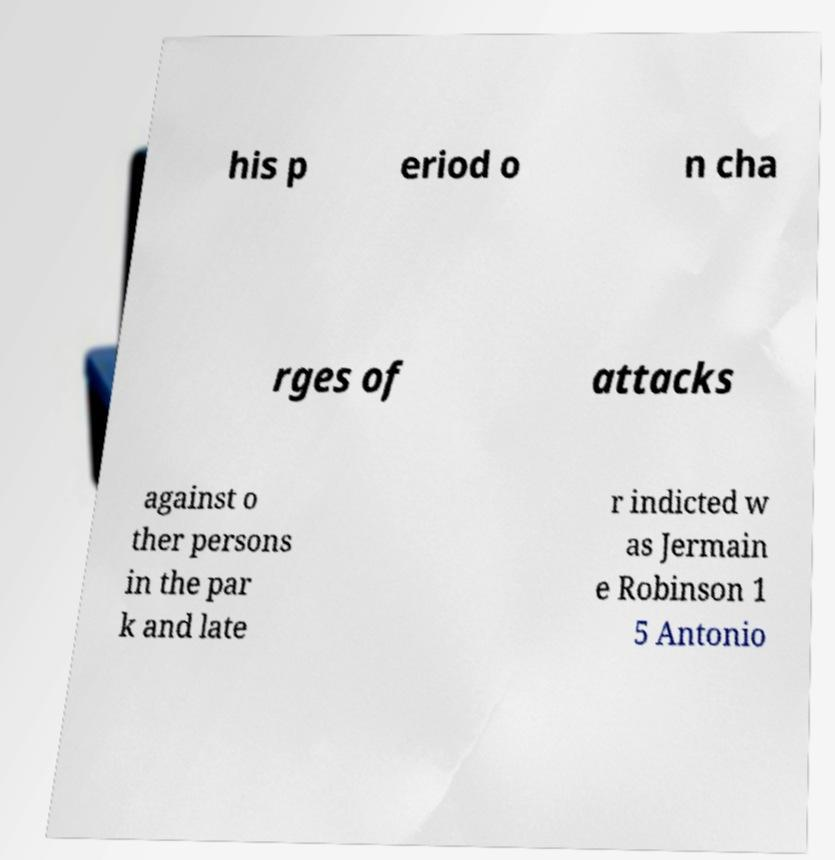Could you assist in decoding the text presented in this image and type it out clearly? his p eriod o n cha rges of attacks against o ther persons in the par k and late r indicted w as Jermain e Robinson 1 5 Antonio 